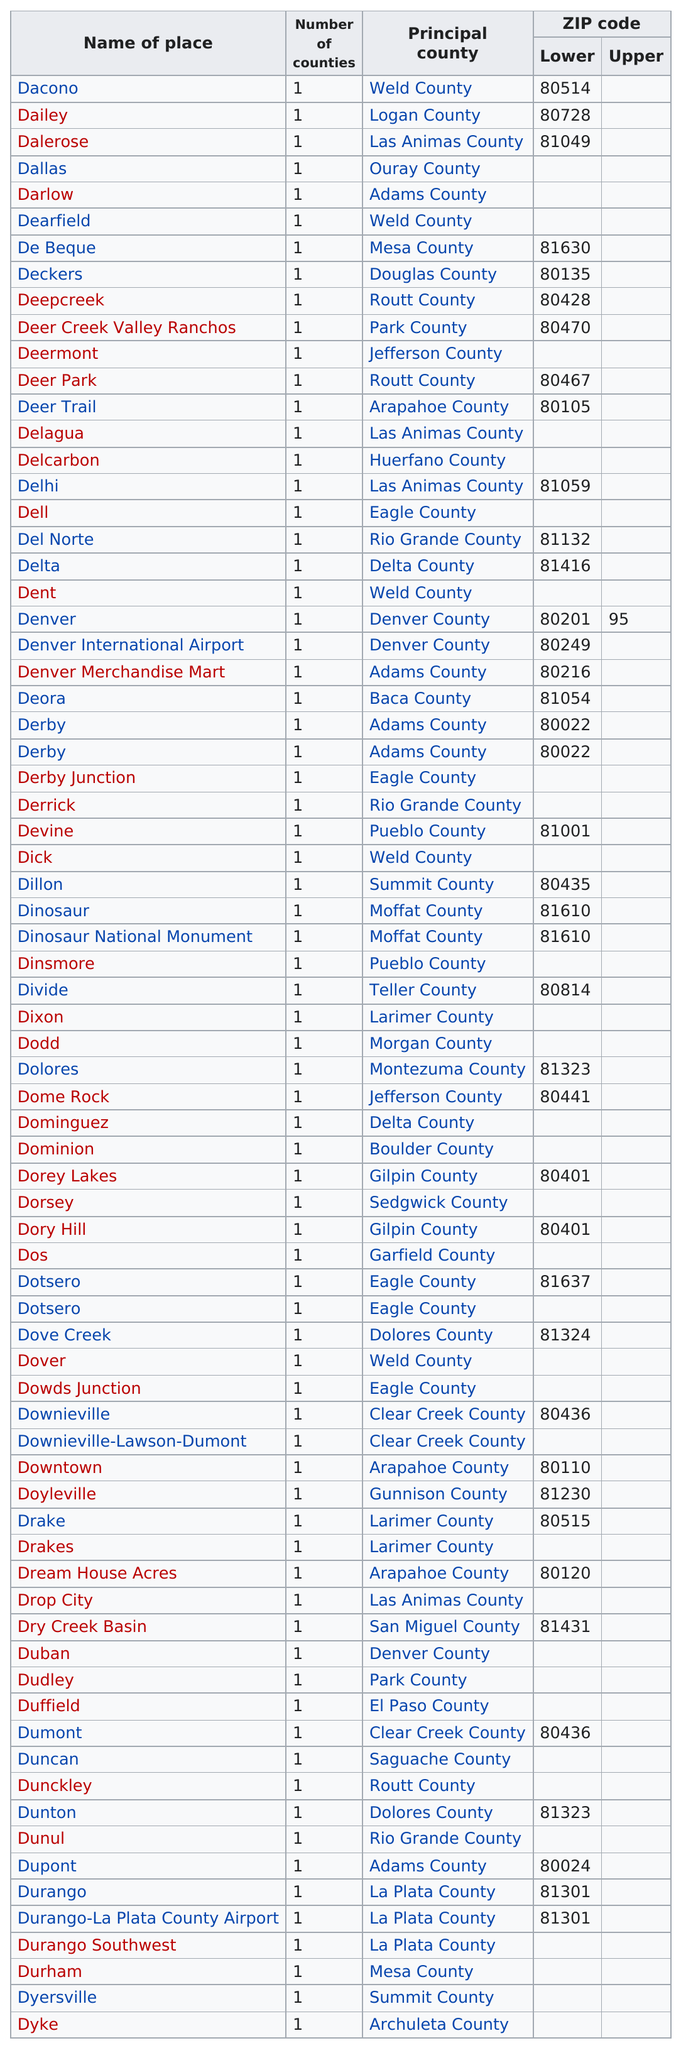Outline some significant characteristics in this image. There are 35 places listed before Dixon. I have listed the place named 'Dyke' at the end of this chart. Can you please provide more information about this place? There are 13 consecutive places that start with the letters "du". Gunnison County is home to approximately 1 individual. There are approximately 40 low ZIP codes in total. 